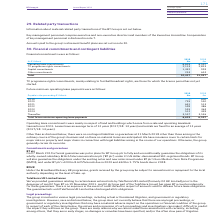From Bt Group Plc's financial document, What was the average term of leases in 2019 and 2018 respectively? The document shows two values: 13 years and 14 years. From the document: "Leases have an average term of 13 years (2017/18: 14 years) and rentals are fixed for an average of 13 years (2017/18: 14 years). Leases have an avera..." Also, What are the contingent liabilities or guarantees at 31 March 2018? there were no contingent liabilities or guarantees at 31 March 2018. The document states: "Other than as disclosed below, there were no contingent liabilities or guarantees at 31 March 2018 other than those arising in the ordinary course of ..." Also, What was the payable in the year ending 31 March 2019 for 2018? According to the financial document, 600 (in millions). The relevant text states: "2019 – 600 2020 755 550 2021 641 513 2022 599 486 2023 555 463 2024 512 449 Thereafter 3,557 3,536..." Also, can you calculate: What was the difference in the payables in year 31 March 2019 for 2018 and 2019? Based on the calculation: 600-0, the result is 600 (in millions). This is based on the information: "BT Group plc Annual Report 2019 2019 – 600 2020 755 550 2021 641 513 2022 599 486 2023 555 463 2024 512 449 Thereafter 3,557 3,536..." Additionally, For which year was  the  Total future minimum operating lease payments be higher? According to the financial document, 2019. The relevant text states: "Payable in the year ending 31 March: 2019 £m 2018 £m..." Additionally, Which year from 2019 to 2024 had the largest payable amount for 2018? According to the financial document, 2020. The relevant text states: "2019 – 600 2020 755 550 2021 641 513 2022 599 486 2023 555 463 2024 512 449 Thereafter 3,557 3,536..." 